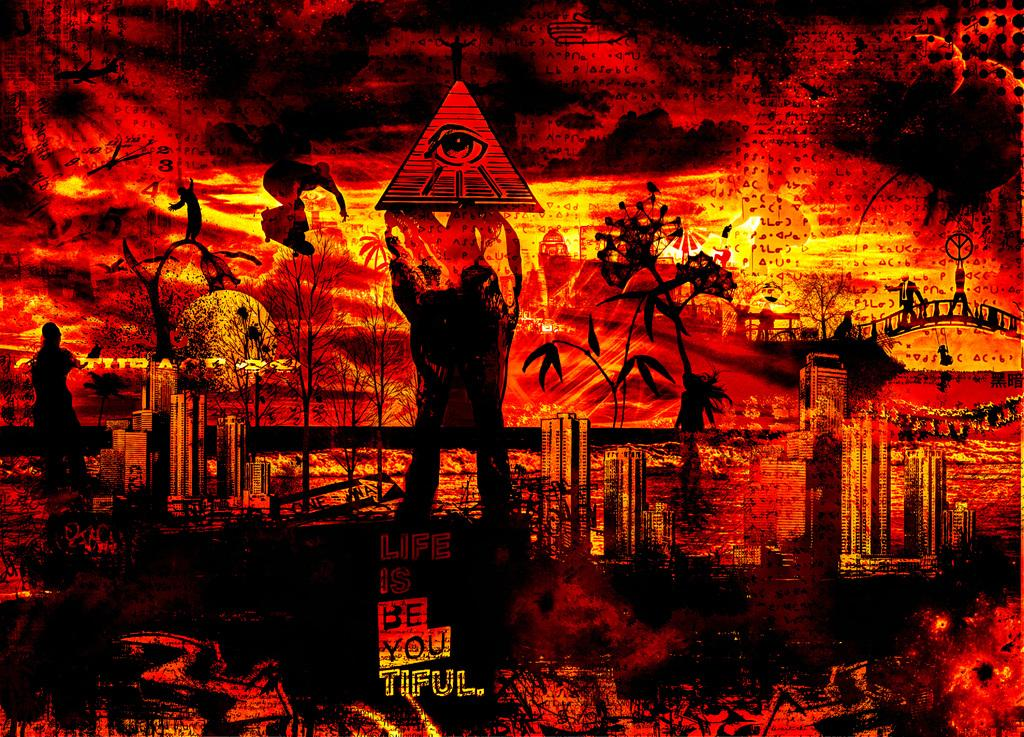What is the main object in the image? There is a board in the image. What type of natural elements can be seen in the image? There are trees in the image. What type of man-made structures are present in the image? There are buildings and a bridge in the image. Are there any people in the image? Yes, there is a person in the image. What colors are used in the image? The image has a color scheme of red, black, and yellow. How many birds are perched on the edge of the bridge in the image? There are no birds present in the image, so it is not possible to answer that question. 